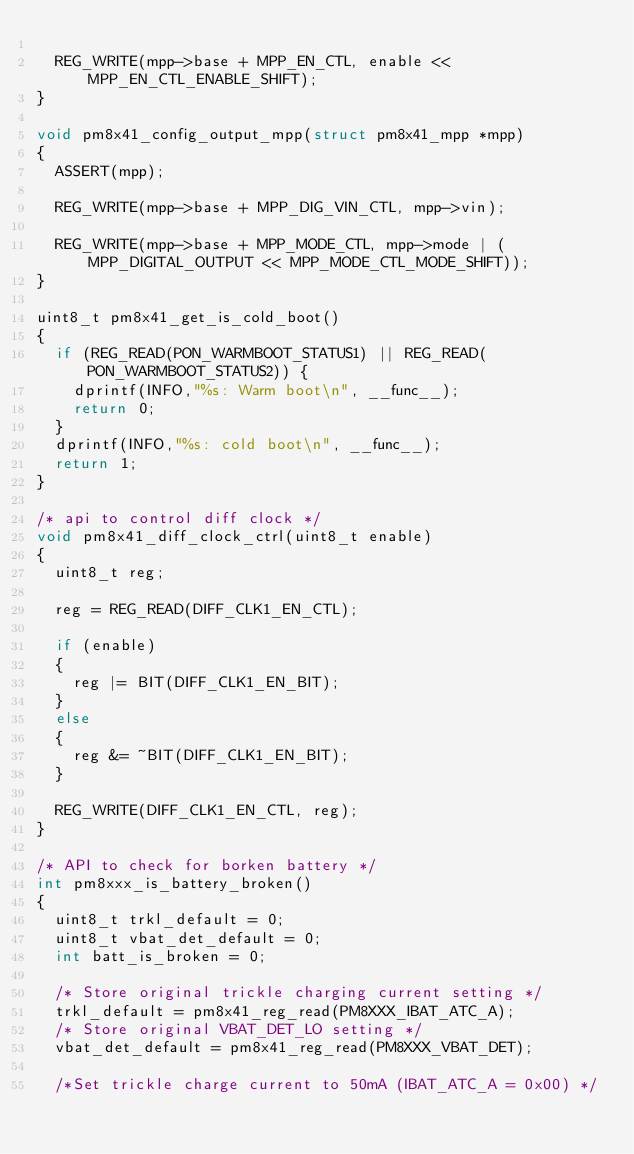Convert code to text. <code><loc_0><loc_0><loc_500><loc_500><_C_>
	REG_WRITE(mpp->base + MPP_EN_CTL, enable << MPP_EN_CTL_ENABLE_SHIFT);
}

void pm8x41_config_output_mpp(struct pm8x41_mpp *mpp)
{
	ASSERT(mpp);

	REG_WRITE(mpp->base + MPP_DIG_VIN_CTL, mpp->vin);

	REG_WRITE(mpp->base + MPP_MODE_CTL, mpp->mode | (MPP_DIGITAL_OUTPUT << MPP_MODE_CTL_MODE_SHIFT));
}

uint8_t pm8x41_get_is_cold_boot()
{
	if (REG_READ(PON_WARMBOOT_STATUS1) || REG_READ(PON_WARMBOOT_STATUS2)) {
		dprintf(INFO,"%s: Warm boot\n", __func__);
		return 0;
	}
	dprintf(INFO,"%s: cold boot\n", __func__);
	return 1;
}

/* api to control diff clock */
void pm8x41_diff_clock_ctrl(uint8_t enable)
{
	uint8_t reg;

	reg = REG_READ(DIFF_CLK1_EN_CTL);

	if (enable)
	{
		reg |= BIT(DIFF_CLK1_EN_BIT);
	}
	else
	{
		reg &= ~BIT(DIFF_CLK1_EN_BIT);
	}

	REG_WRITE(DIFF_CLK1_EN_CTL, reg);
}

/* API to check for borken battery */
int pm8xxx_is_battery_broken()
{
	uint8_t trkl_default = 0;
	uint8_t vbat_det_default = 0;
	int batt_is_broken = 0;

	/* Store original trickle charging current setting */
	trkl_default = pm8x41_reg_read(PM8XXX_IBAT_ATC_A);
	/* Store original VBAT_DET_LO setting */
	vbat_det_default = pm8x41_reg_read(PM8XXX_VBAT_DET);

	/*Set trickle charge current to 50mA (IBAT_ATC_A = 0x00) */</code> 